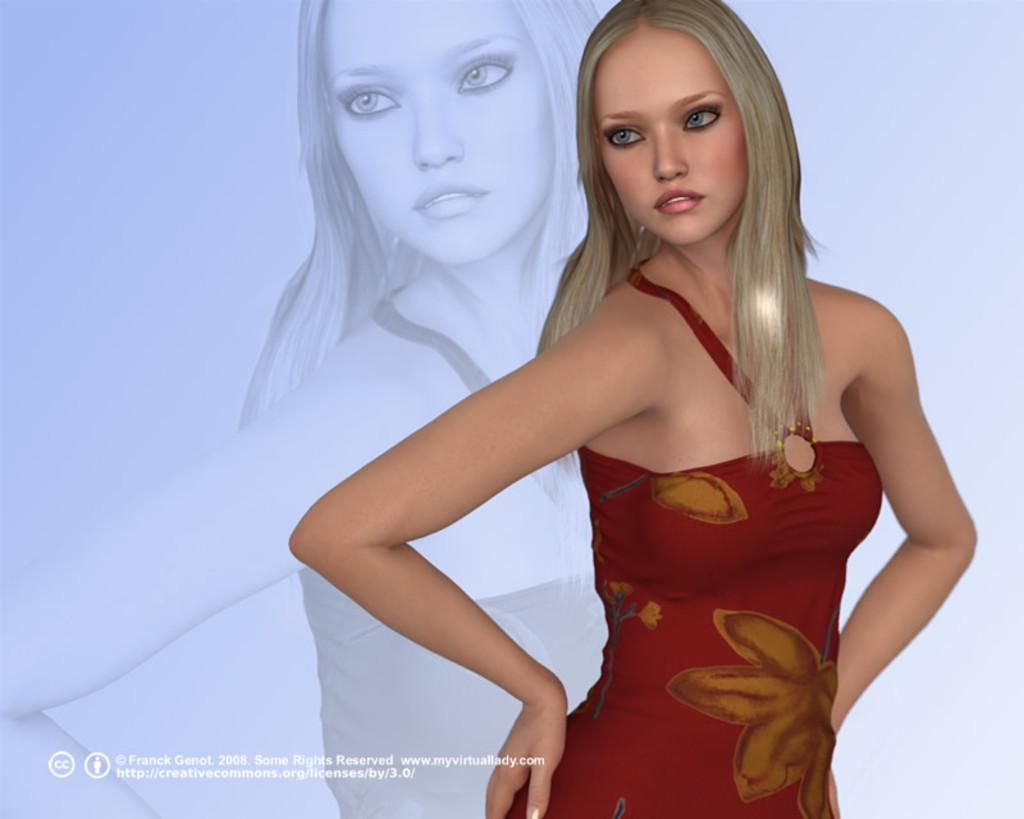What is the main subject of the image? The main subject of the image is an animated picture of a woman standing. Can you describe the text in the image? There is some text in the bottom left corner of the image. What type of jam is being served in the image? There is no jam present in the image; it features an animated picture of a woman standing and some text in the bottom left corner. 